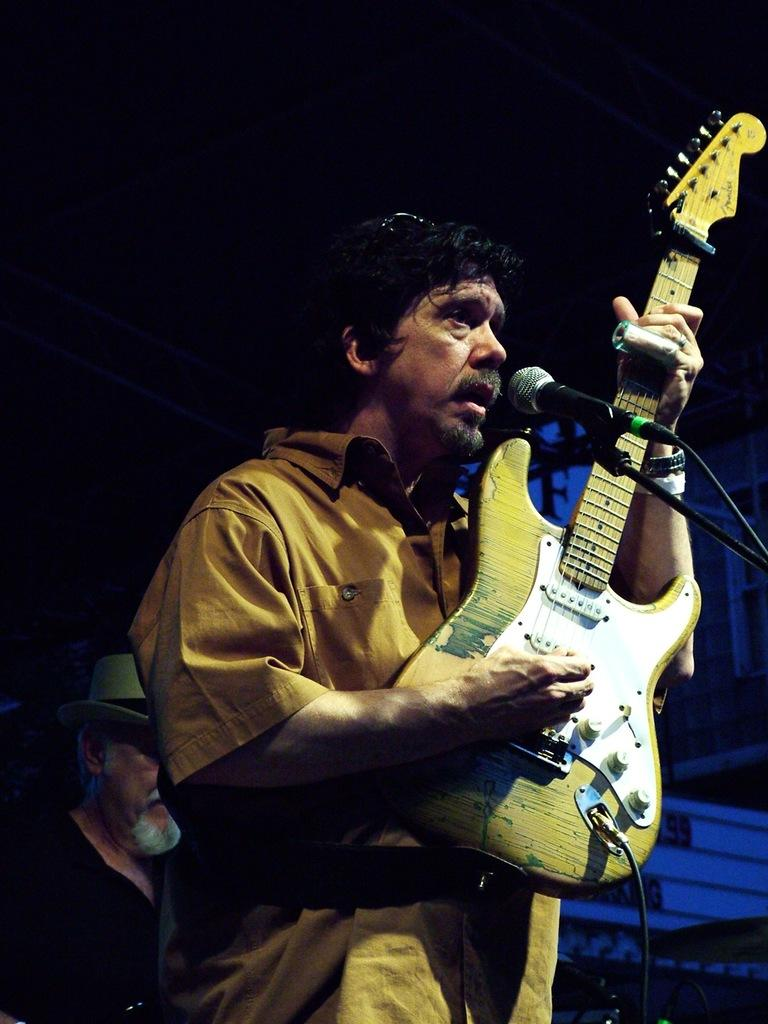What is the man in the image doing? The man is playing a guitar. What object is present in the image that is typically used for amplifying sound? There is a microphone (mike) in the image. How many clocks can be seen hanging on the wall in the image? There are no clocks visible in the image. What type of clouds can be seen in the image? There are no clouds present in the image. What word is the man saying into the microphone in the image? We cannot determine what word the man is saying into the microphone based on the information provided in the image. 